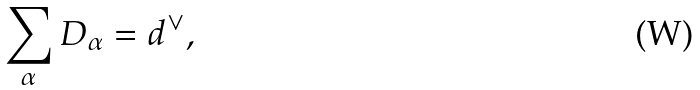<formula> <loc_0><loc_0><loc_500><loc_500>\sum _ { \alpha } D _ { \alpha } = d ^ { \vee } ,</formula> 